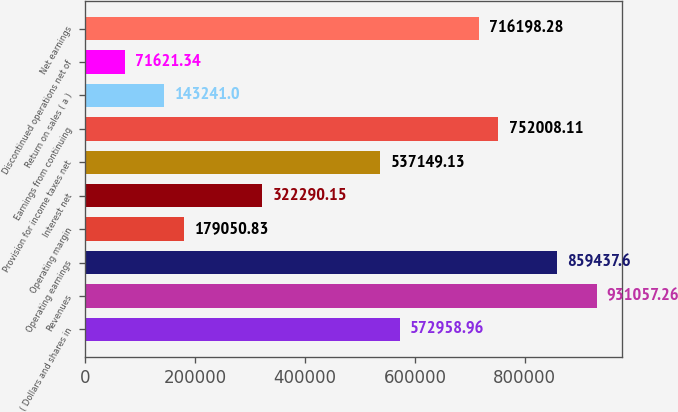<chart> <loc_0><loc_0><loc_500><loc_500><bar_chart><fcel>( Dollars and shares in<fcel>Revenues<fcel>Operating earnings<fcel>Operating margin<fcel>Interest net<fcel>Provision for income taxes net<fcel>Earnings from continuing<fcel>Return on sales ( a )<fcel>Discontinued operations net of<fcel>Net earnings<nl><fcel>572959<fcel>931057<fcel>859438<fcel>179051<fcel>322290<fcel>537149<fcel>752008<fcel>143241<fcel>71621.3<fcel>716198<nl></chart> 